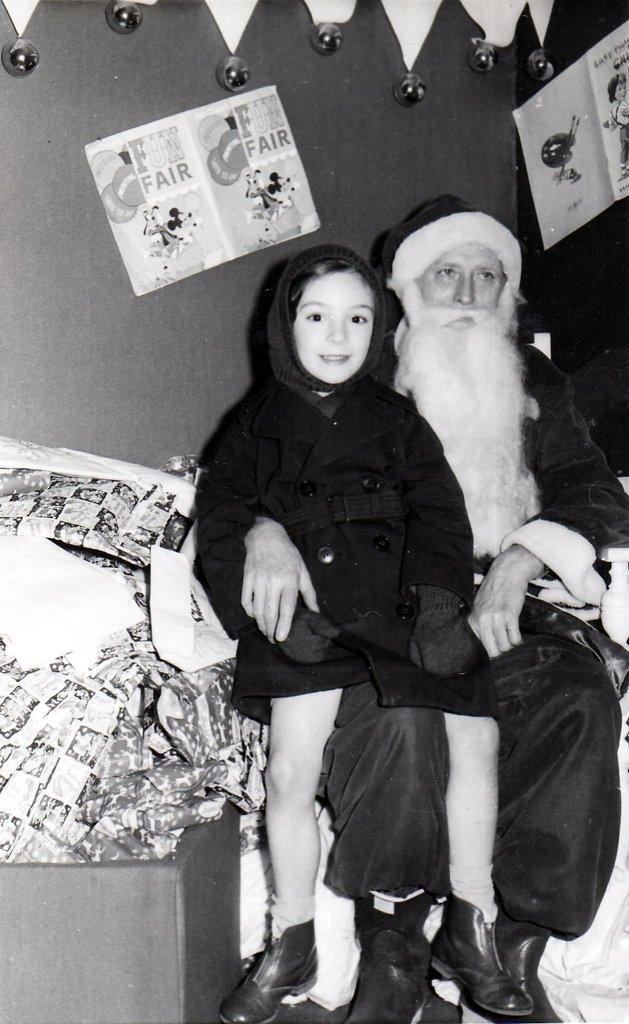Please provide a concise description of this image. This is a black and white picture. Here we can see two persons, posters, and few objects. In the background there is a wall. 